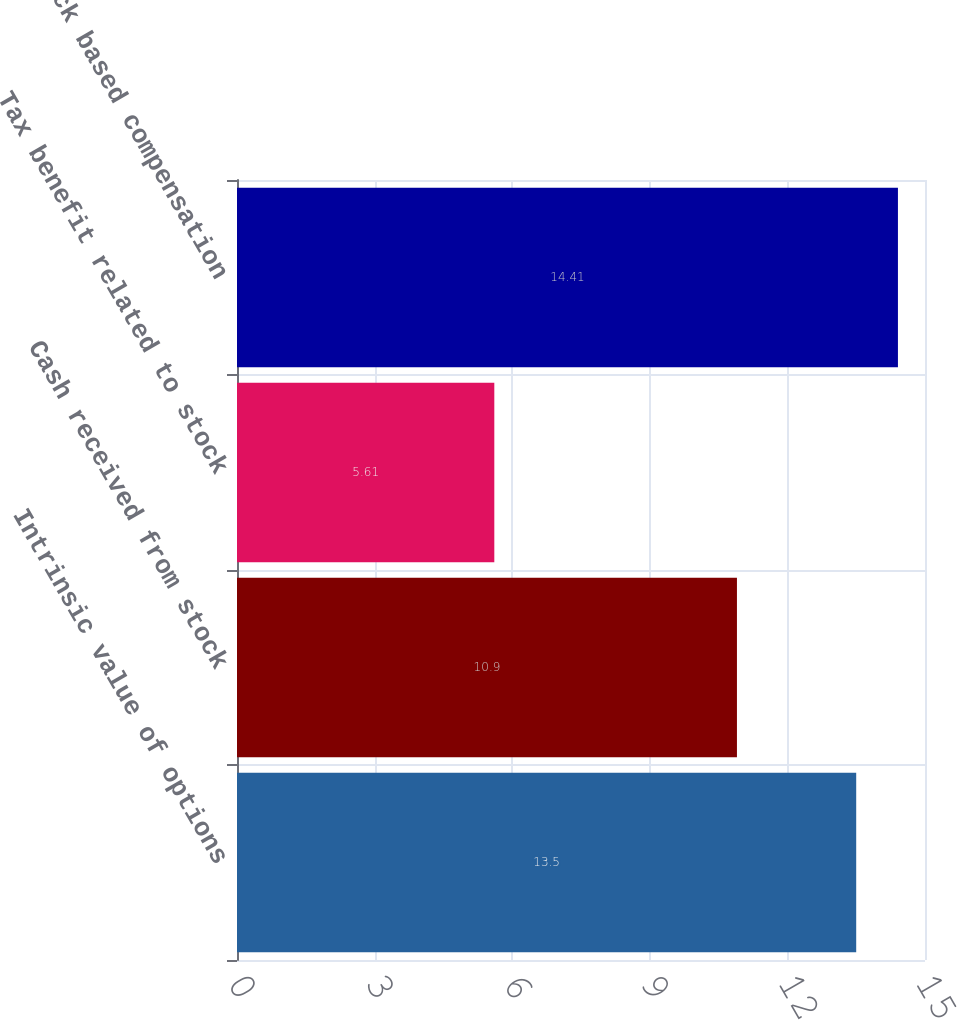Convert chart to OTSL. <chart><loc_0><loc_0><loc_500><loc_500><bar_chart><fcel>Intrinsic value of options<fcel>Cash received from stock<fcel>Tax benefit related to stock<fcel>Stock based compensation<nl><fcel>13.5<fcel>10.9<fcel>5.61<fcel>14.41<nl></chart> 